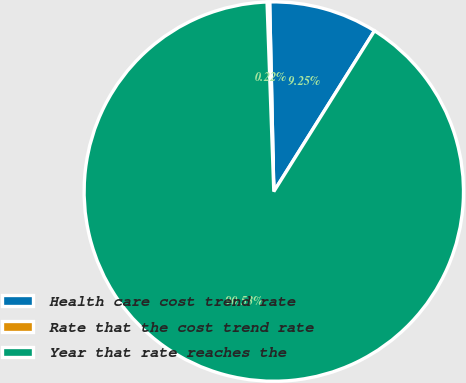<chart> <loc_0><loc_0><loc_500><loc_500><pie_chart><fcel>Health care cost trend rate<fcel>Rate that the cost trend rate<fcel>Year that rate reaches the<nl><fcel>9.25%<fcel>0.22%<fcel>90.52%<nl></chart> 